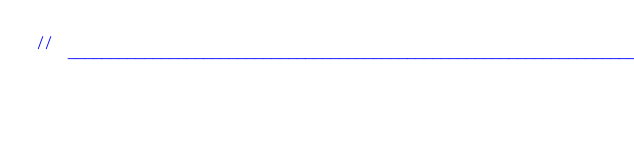Convert code to text. <code><loc_0><loc_0><loc_500><loc_500><_C#_>// ------------------------------------------------------------------------------</code> 